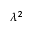<formula> <loc_0><loc_0><loc_500><loc_500>\lambda ^ { 2 }</formula> 